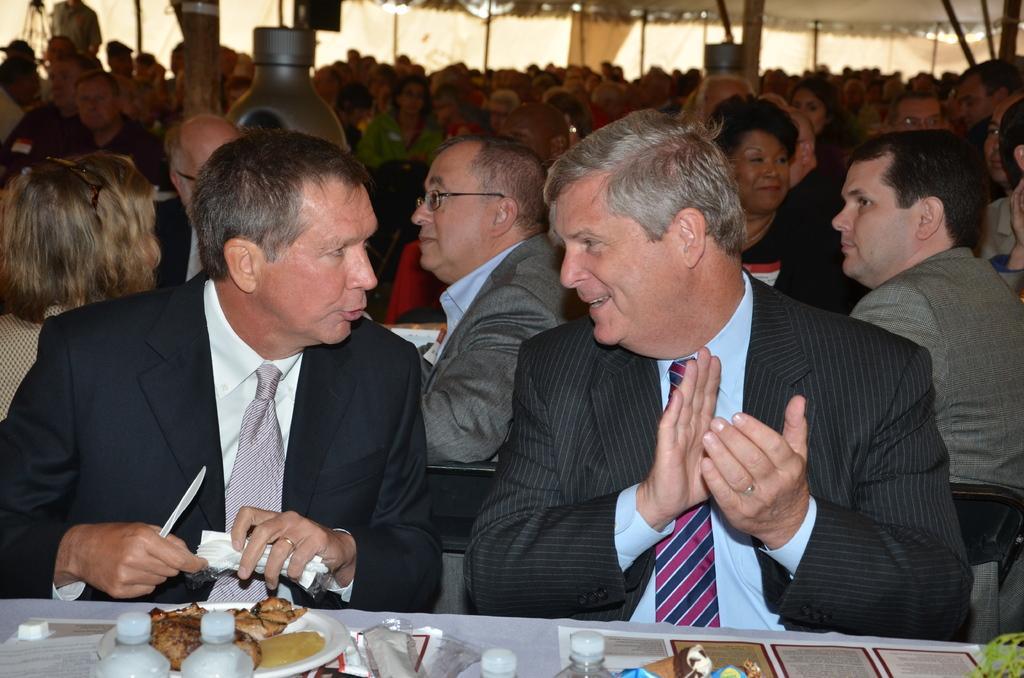How would you summarize this image in a sentence or two? In this picture we can see two men wore blazers, ties and in front of them we can see bottles, plate with food items on it, papers and at the back of them we can see a group of people, clothes and some objects. 